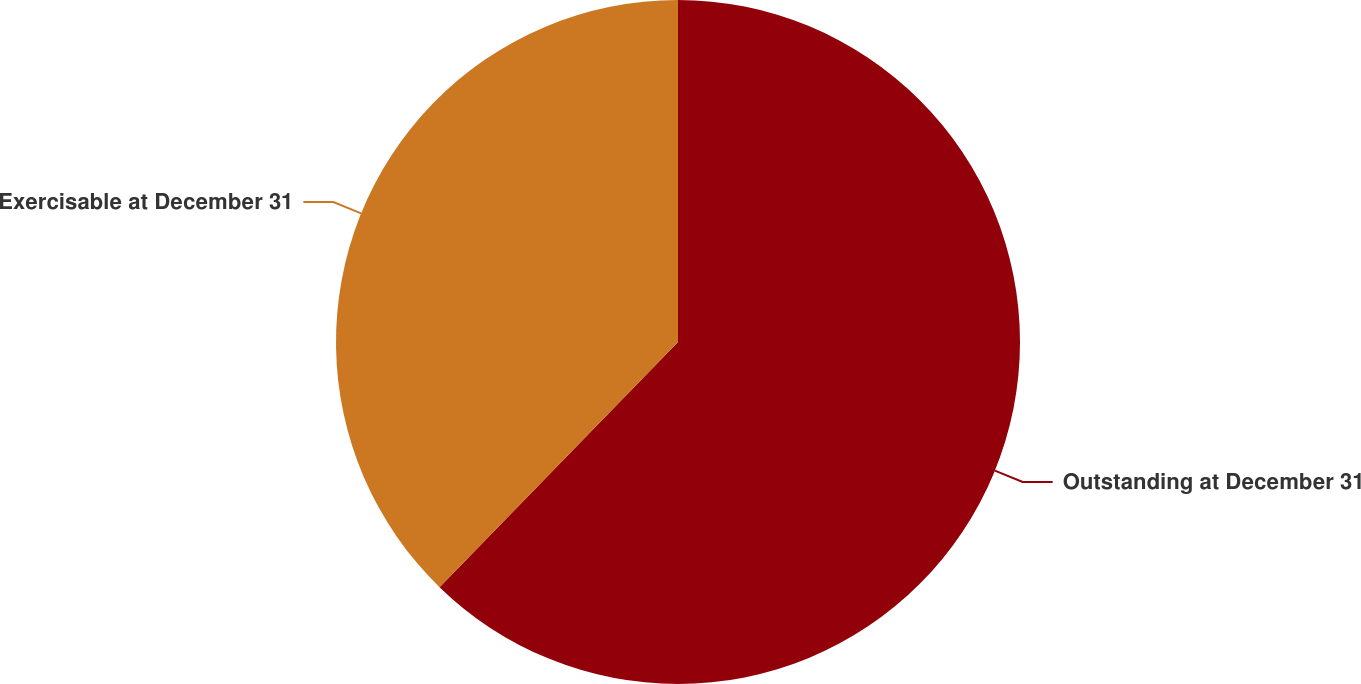Convert chart to OTSL. <chart><loc_0><loc_0><loc_500><loc_500><pie_chart><fcel>Outstanding at December 31<fcel>Exercisable at December 31<nl><fcel>62.28%<fcel>37.72%<nl></chart> 